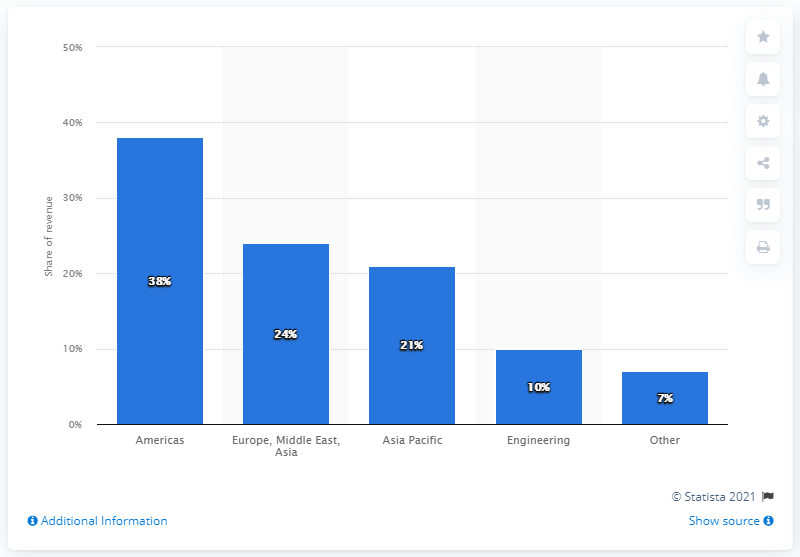Draw attention to some important aspects in this diagram. In 2020, Linde plc's sales in North and South America accounted for 38% of the company's overall sales. 